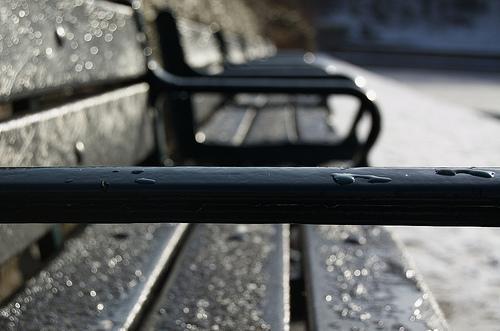How many benches are in the picture?
Give a very brief answer. 3. 